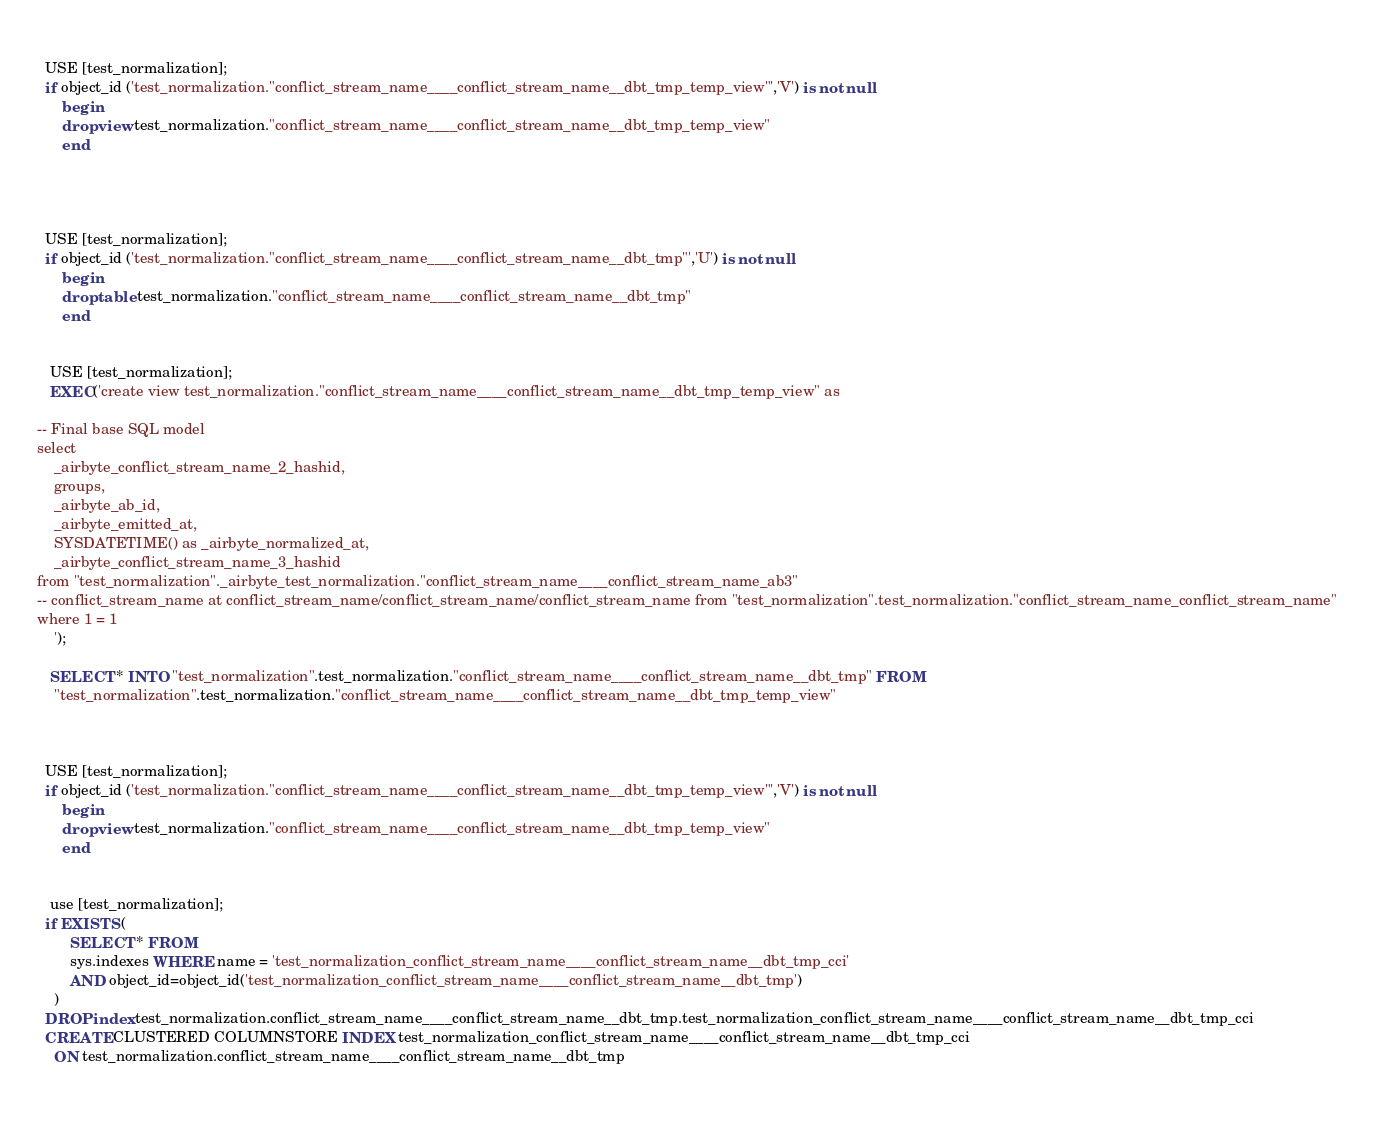Convert code to text. <code><loc_0><loc_0><loc_500><loc_500><_SQL_>
   
  USE [test_normalization];
  if object_id ('test_normalization."conflict_stream_name____conflict_stream_name__dbt_tmp_temp_view"','V') is not null
      begin
      drop view test_normalization."conflict_stream_name____conflict_stream_name__dbt_tmp_temp_view"
      end


   
   
  USE [test_normalization];
  if object_id ('test_normalization."conflict_stream_name____conflict_stream_name__dbt_tmp"','U') is not null
      begin
      drop table test_normalization."conflict_stream_name____conflict_stream_name__dbt_tmp"
      end


   USE [test_normalization];
   EXEC('create view test_normalization."conflict_stream_name____conflict_stream_name__dbt_tmp_temp_view" as
    
-- Final base SQL model
select
    _airbyte_conflict_stream_name_2_hashid,
    groups,
    _airbyte_ab_id,
    _airbyte_emitted_at,
    SYSDATETIME() as _airbyte_normalized_at,
    _airbyte_conflict_stream_name_3_hashid
from "test_normalization"._airbyte_test_normalization."conflict_stream_name____conflict_stream_name_ab3"
-- conflict_stream_name at conflict_stream_name/conflict_stream_name/conflict_stream_name from "test_normalization".test_normalization."conflict_stream_name_conflict_stream_name"
where 1 = 1
    ');

   SELECT * INTO "test_normalization".test_normalization."conflict_stream_name____conflict_stream_name__dbt_tmp" FROM
    "test_normalization".test_normalization."conflict_stream_name____conflict_stream_name__dbt_tmp_temp_view"

   
   
  USE [test_normalization];
  if object_id ('test_normalization."conflict_stream_name____conflict_stream_name__dbt_tmp_temp_view"','V') is not null
      begin
      drop view test_normalization."conflict_stream_name____conflict_stream_name__dbt_tmp_temp_view"
      end

    
   use [test_normalization];
  if EXISTS (
        SELECT * FROM
        sys.indexes WHERE name = 'test_normalization_conflict_stream_name____conflict_stream_name__dbt_tmp_cci'
        AND object_id=object_id('test_normalization_conflict_stream_name____conflict_stream_name__dbt_tmp')
    )
  DROP index test_normalization.conflict_stream_name____conflict_stream_name__dbt_tmp.test_normalization_conflict_stream_name____conflict_stream_name__dbt_tmp_cci
  CREATE CLUSTERED COLUMNSTORE INDEX test_normalization_conflict_stream_name____conflict_stream_name__dbt_tmp_cci
    ON test_normalization.conflict_stream_name____conflict_stream_name__dbt_tmp

   

</code> 